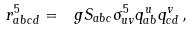Convert formula to latex. <formula><loc_0><loc_0><loc_500><loc_500>r ^ { 5 } _ { a b c d } = \ g S _ { a b c } \sigma ^ { 5 } _ { u v } q ^ { u } _ { a b } q ^ { v } _ { c d } \, ,</formula> 